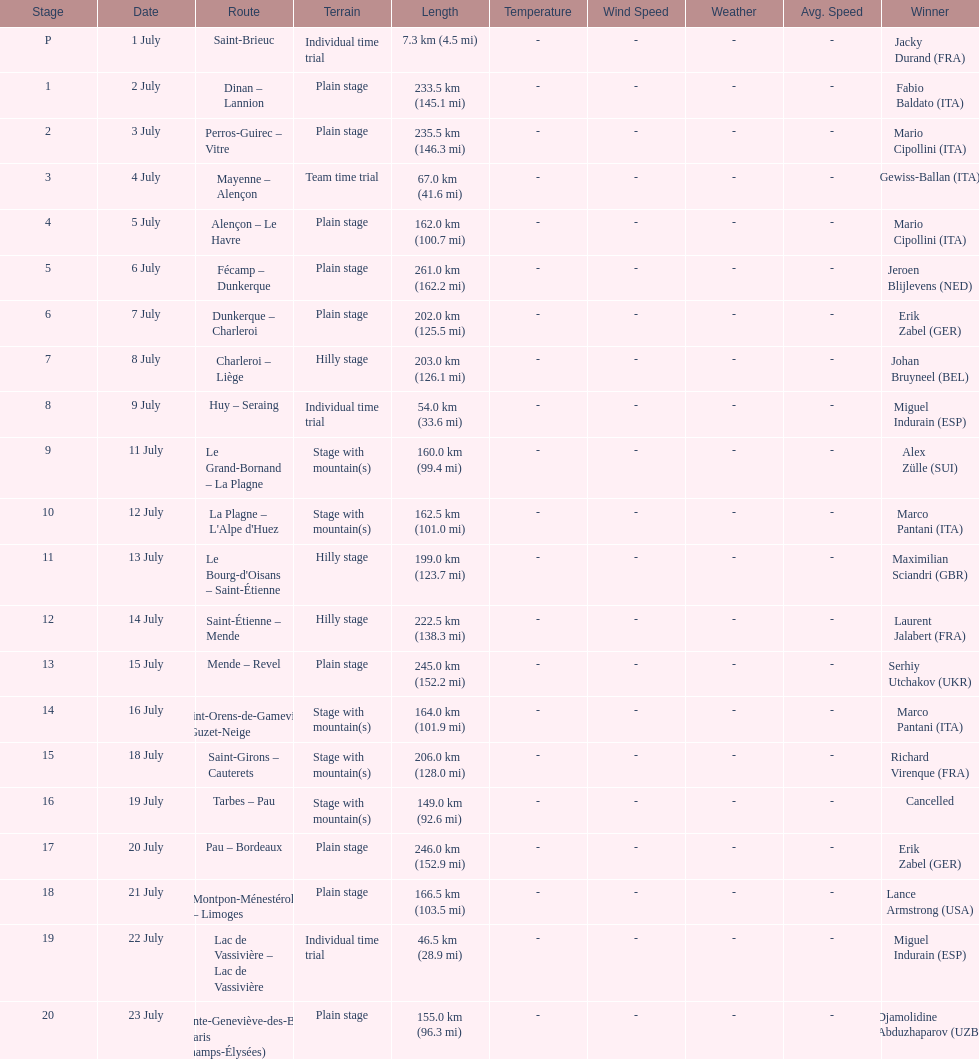How many consecutive km were raced on july 8th? 203.0 km (126.1 mi). 